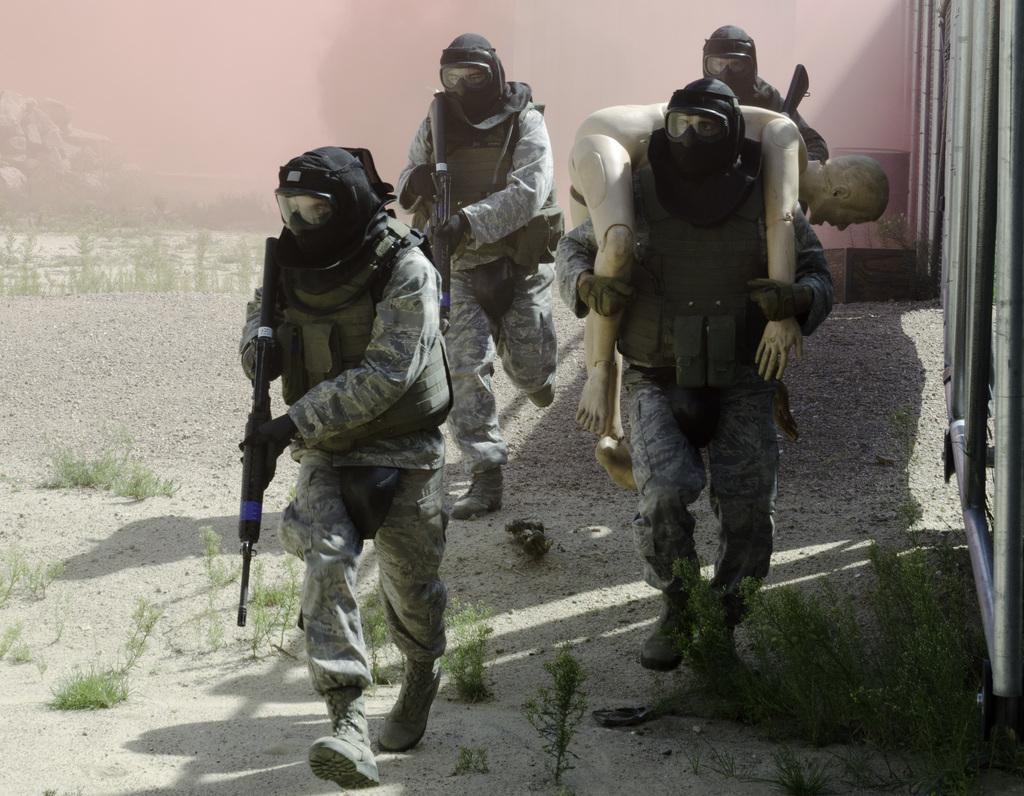How many people are in the image? There are four people in the image. What are the people doing in the image? The people are walking. Can you describe what one person is holding in the image? One person is holding an object. What are the other three people holding in the image? The other three people are holding guns. What type of natural elements can be seen in the image? There are plants and stones in the image. How does the pancake get sorted in the image? There is no pancake present in the image, so it cannot be sorted. 